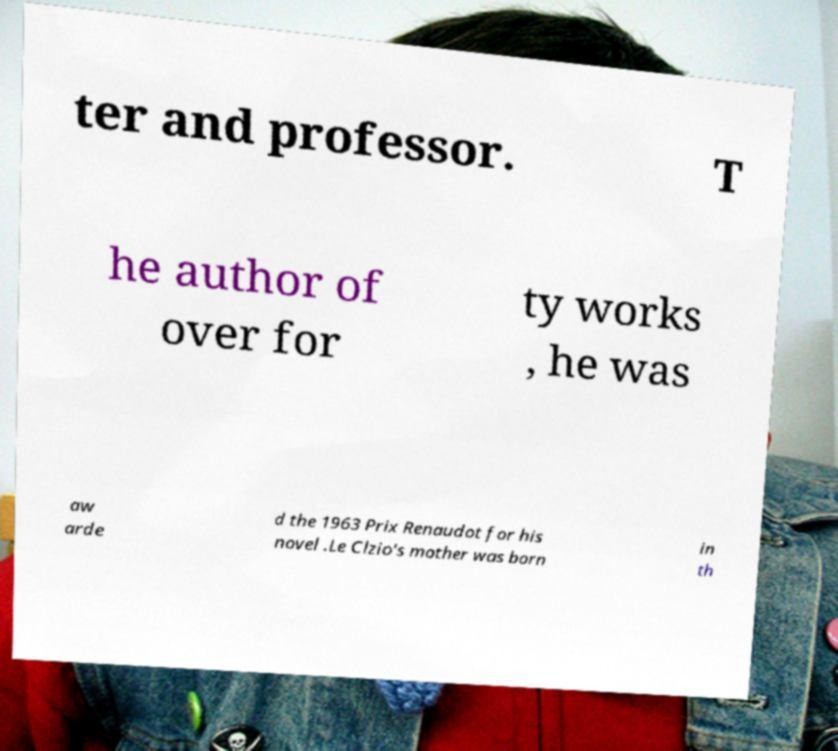Can you read and provide the text displayed in the image?This photo seems to have some interesting text. Can you extract and type it out for me? ter and professor. T he author of over for ty works , he was aw arde d the 1963 Prix Renaudot for his novel .Le Clzio's mother was born in th 